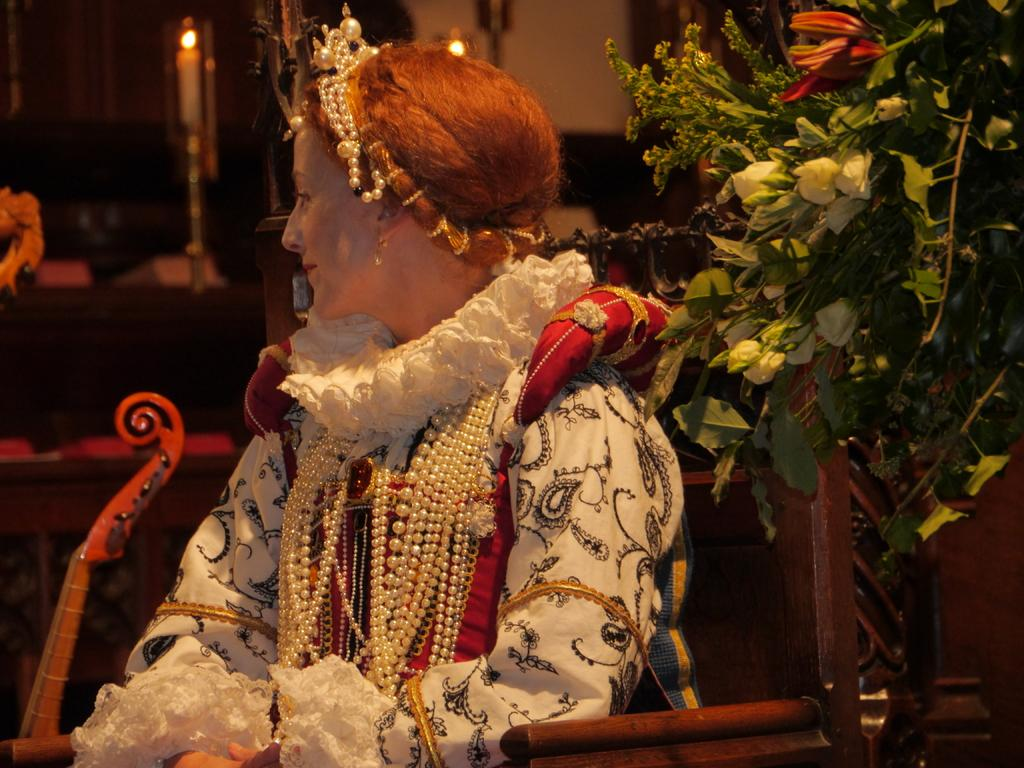Who is the main subject in the picture? There is a woman in the picture. What is the woman doing in the image? The woman is sitting on a chair. What accessories is the woman wearing in the image? The woman is wearing necklaces and a crown. What can be seen in the backdrop of the image? There is a candle stand and a wall in the backdrop. What color are the apples on the wall in the image? There are no apples present in the image; the backdrop features a wall and a candle stand. 